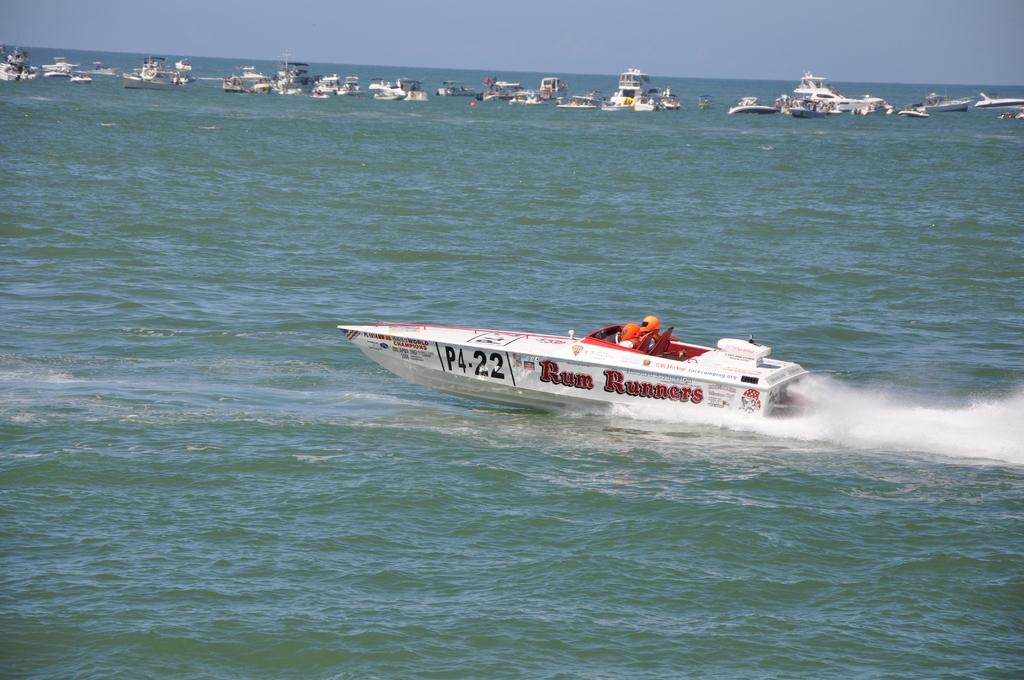What type of vehicles are in the water in the image? There are boats in the water in the image. Are there any people on the boats? Yes, two people are on one of the boats. What are the people on the boat wearing? The people on the boat are wearing helmets. What can be seen in the background of the image? The sky is visible in the background of the image. Where is the desk located in the image? There is no desk present in the image; it features boats in the water. What type of shoes are the people wearing on the boat? The people on the boat are wearing helmets, not shoes, so we cannot determine their shoe type from the image. 